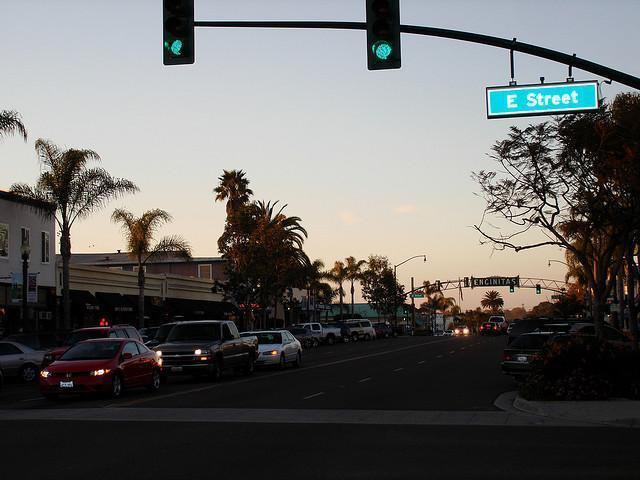How many sets of traffic lights can be seen?
Give a very brief answer. 2. How many traffic lights are in this street?
Give a very brief answer. 4. How many cars can you see?
Give a very brief answer. 2. How many scissors are to the left of the yarn?
Give a very brief answer. 0. 